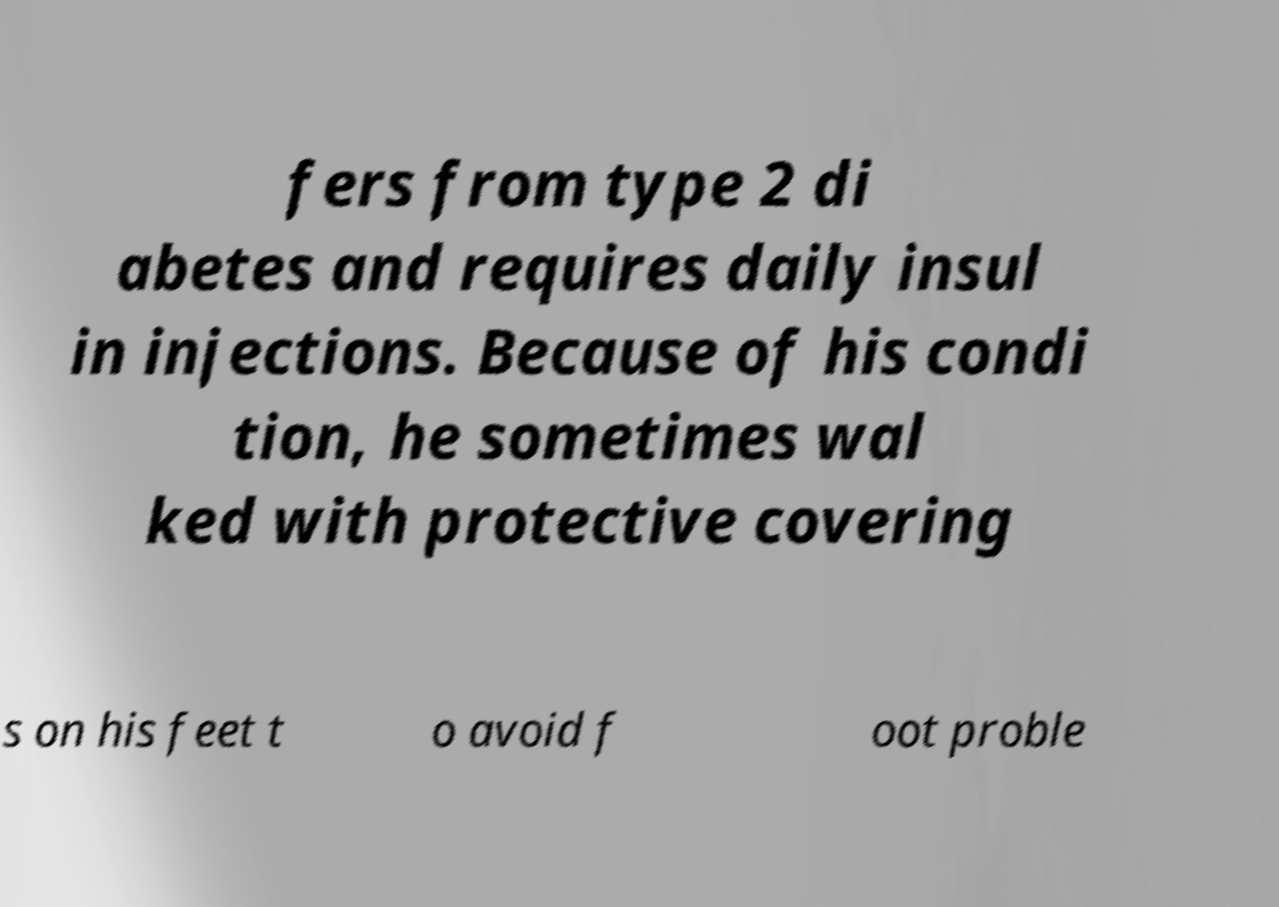There's text embedded in this image that I need extracted. Can you transcribe it verbatim? fers from type 2 di abetes and requires daily insul in injections. Because of his condi tion, he sometimes wal ked with protective covering s on his feet t o avoid f oot proble 